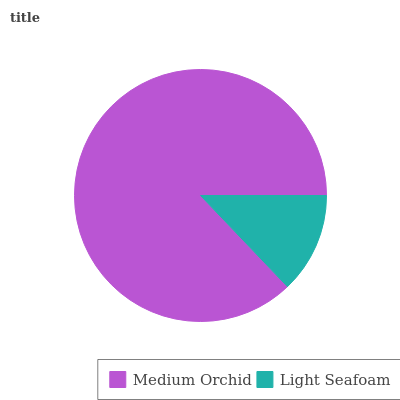Is Light Seafoam the minimum?
Answer yes or no. Yes. Is Medium Orchid the maximum?
Answer yes or no. Yes. Is Light Seafoam the maximum?
Answer yes or no. No. Is Medium Orchid greater than Light Seafoam?
Answer yes or no. Yes. Is Light Seafoam less than Medium Orchid?
Answer yes or no. Yes. Is Light Seafoam greater than Medium Orchid?
Answer yes or no. No. Is Medium Orchid less than Light Seafoam?
Answer yes or no. No. Is Medium Orchid the high median?
Answer yes or no. Yes. Is Light Seafoam the low median?
Answer yes or no. Yes. Is Light Seafoam the high median?
Answer yes or no. No. Is Medium Orchid the low median?
Answer yes or no. No. 